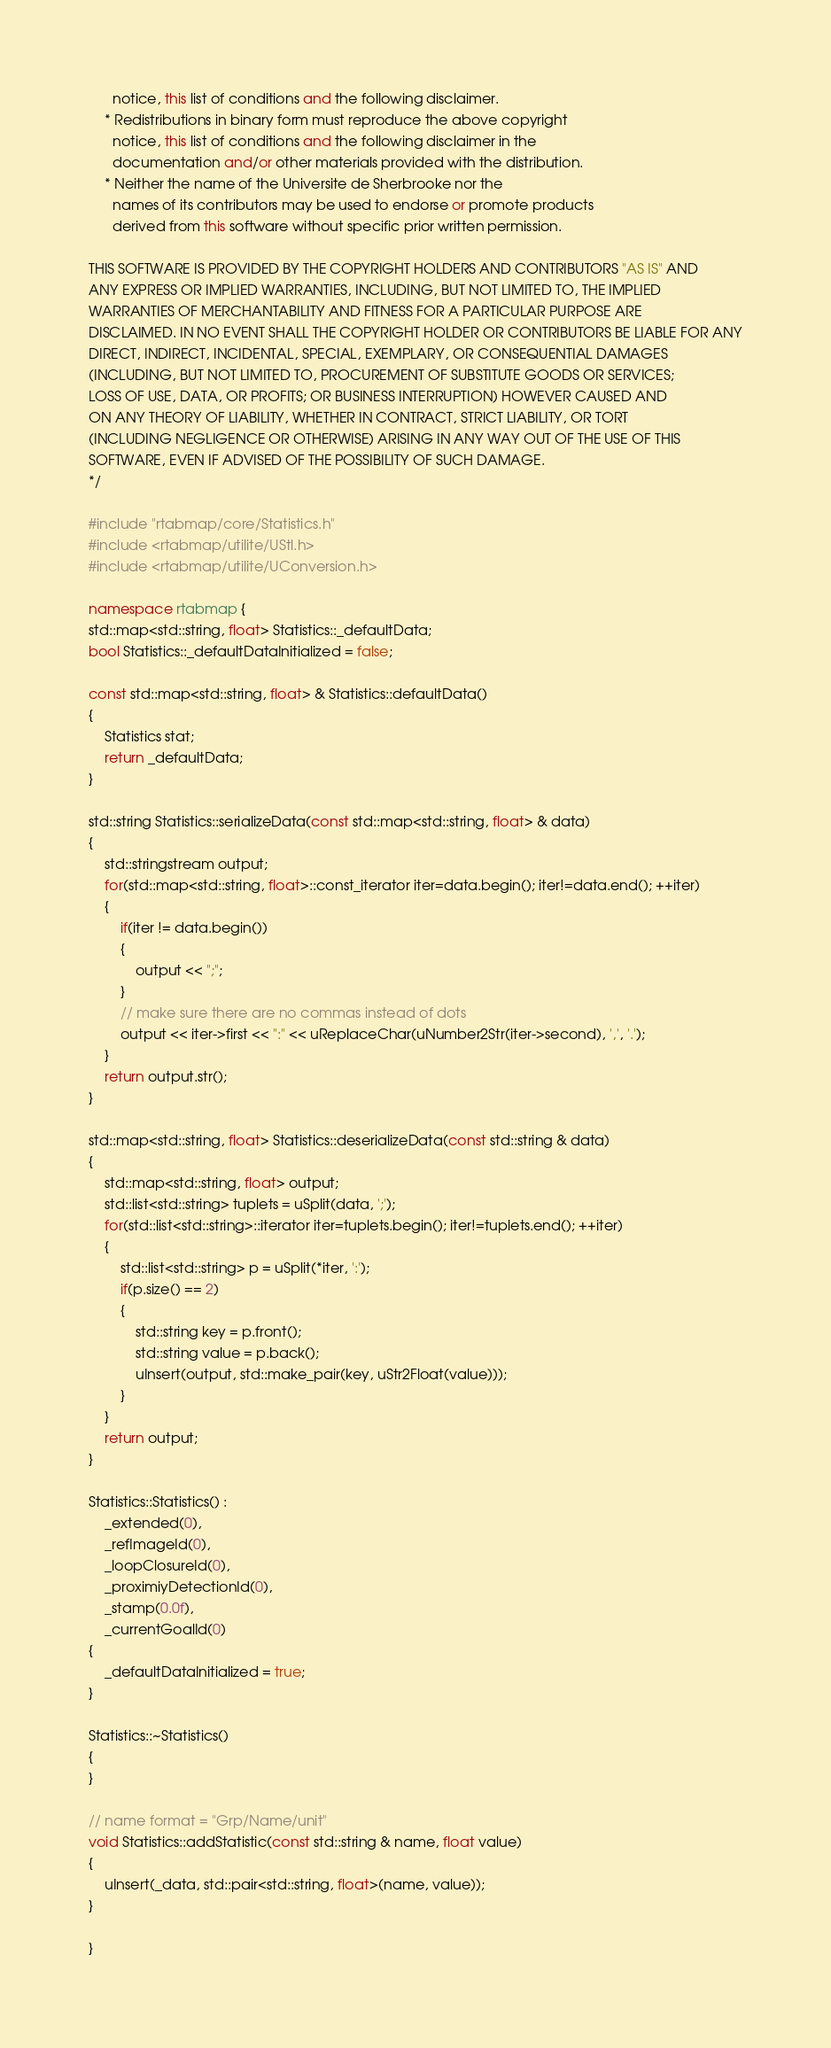<code> <loc_0><loc_0><loc_500><loc_500><_C++_>      notice, this list of conditions and the following disclaimer.
    * Redistributions in binary form must reproduce the above copyright
      notice, this list of conditions and the following disclaimer in the
      documentation and/or other materials provided with the distribution.
    * Neither the name of the Universite de Sherbrooke nor the
      names of its contributors may be used to endorse or promote products
      derived from this software without specific prior written permission.

THIS SOFTWARE IS PROVIDED BY THE COPYRIGHT HOLDERS AND CONTRIBUTORS "AS IS" AND
ANY EXPRESS OR IMPLIED WARRANTIES, INCLUDING, BUT NOT LIMITED TO, THE IMPLIED
WARRANTIES OF MERCHANTABILITY AND FITNESS FOR A PARTICULAR PURPOSE ARE
DISCLAIMED. IN NO EVENT SHALL THE COPYRIGHT HOLDER OR CONTRIBUTORS BE LIABLE FOR ANY
DIRECT, INDIRECT, INCIDENTAL, SPECIAL, EXEMPLARY, OR CONSEQUENTIAL DAMAGES
(INCLUDING, BUT NOT LIMITED TO, PROCUREMENT OF SUBSTITUTE GOODS OR SERVICES;
LOSS OF USE, DATA, OR PROFITS; OR BUSINESS INTERRUPTION) HOWEVER CAUSED AND
ON ANY THEORY OF LIABILITY, WHETHER IN CONTRACT, STRICT LIABILITY, OR TORT
(INCLUDING NEGLIGENCE OR OTHERWISE) ARISING IN ANY WAY OUT OF THE USE OF THIS
SOFTWARE, EVEN IF ADVISED OF THE POSSIBILITY OF SUCH DAMAGE.
*/

#include "rtabmap/core/Statistics.h"
#include <rtabmap/utilite/UStl.h>
#include <rtabmap/utilite/UConversion.h>

namespace rtabmap {
std::map<std::string, float> Statistics::_defaultData;
bool Statistics::_defaultDataInitialized = false;

const std::map<std::string, float> & Statistics::defaultData()
{
	Statistics stat;
	return _defaultData;
}

std::string Statistics::serializeData(const std::map<std::string, float> & data)
{
	std::stringstream output;
	for(std::map<std::string, float>::const_iterator iter=data.begin(); iter!=data.end(); ++iter)
	{
		if(iter != data.begin())
		{
			output << ";";
		}
		// make sure there are no commas instead of dots
		output << iter->first << ":" << uReplaceChar(uNumber2Str(iter->second), ',', '.');
	}
	return output.str();
}

std::map<std::string, float> Statistics::deserializeData(const std::string & data)
{
	std::map<std::string, float> output;
	std::list<std::string> tuplets = uSplit(data, ';');
	for(std::list<std::string>::iterator iter=tuplets.begin(); iter!=tuplets.end(); ++iter)
	{
		std::list<std::string> p = uSplit(*iter, ':');
		if(p.size() == 2)
		{
			std::string key = p.front();
			std::string value = p.back();
			uInsert(output, std::make_pair(key, uStr2Float(value)));
		}
	}
	return output;
}

Statistics::Statistics() :
	_extended(0),
	_refImageId(0),
	_loopClosureId(0),
	_proximiyDetectionId(0),
	_stamp(0.0f),
	_currentGoalId(0)
{
	_defaultDataInitialized = true;
}

Statistics::~Statistics()
{
}

// name format = "Grp/Name/unit"
void Statistics::addStatistic(const std::string & name, float value)
{
	uInsert(_data, std::pair<std::string, float>(name, value));
}

}
</code> 